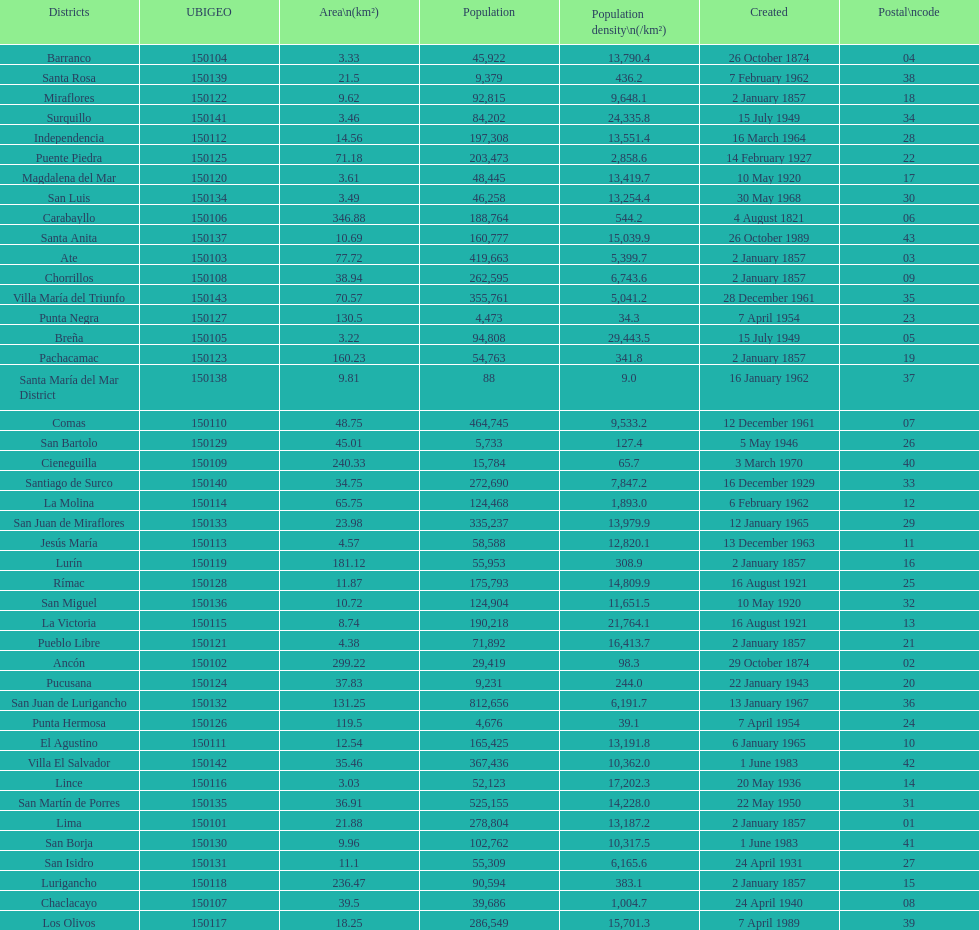Which district in this city has the greatest population? San Juan de Lurigancho. 